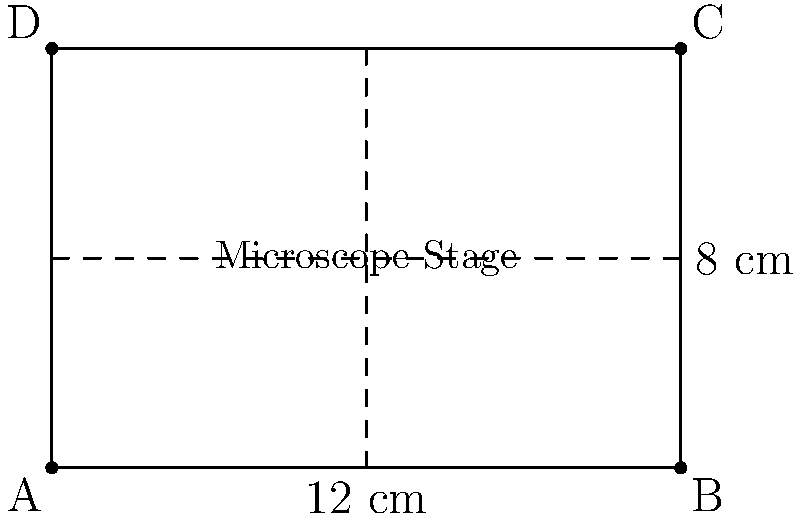As a parasitologist, you're setting up a new microscope for your research. The rectangular microscope stage measures 12 cm in length and 8 cm in width. What is the perimeter of the microscope stage? To find the perimeter of a rectangle, we need to add up the lengths of all four sides. Let's break this down step-by-step:

1. Identify the given dimensions:
   Length (l) = 12 cm
   Width (w) = 8 cm

2. Recall the formula for the perimeter of a rectangle:
   Perimeter = 2(length + width) or P = 2(l + w)

3. Substitute the values into the formula:
   P = 2(12 cm + 8 cm)

4. Calculate the sum inside the parentheses:
   P = 2(20 cm)

5. Multiply:
   P = 40 cm

Therefore, the perimeter of the microscope stage is 40 cm.
Answer: 40 cm 